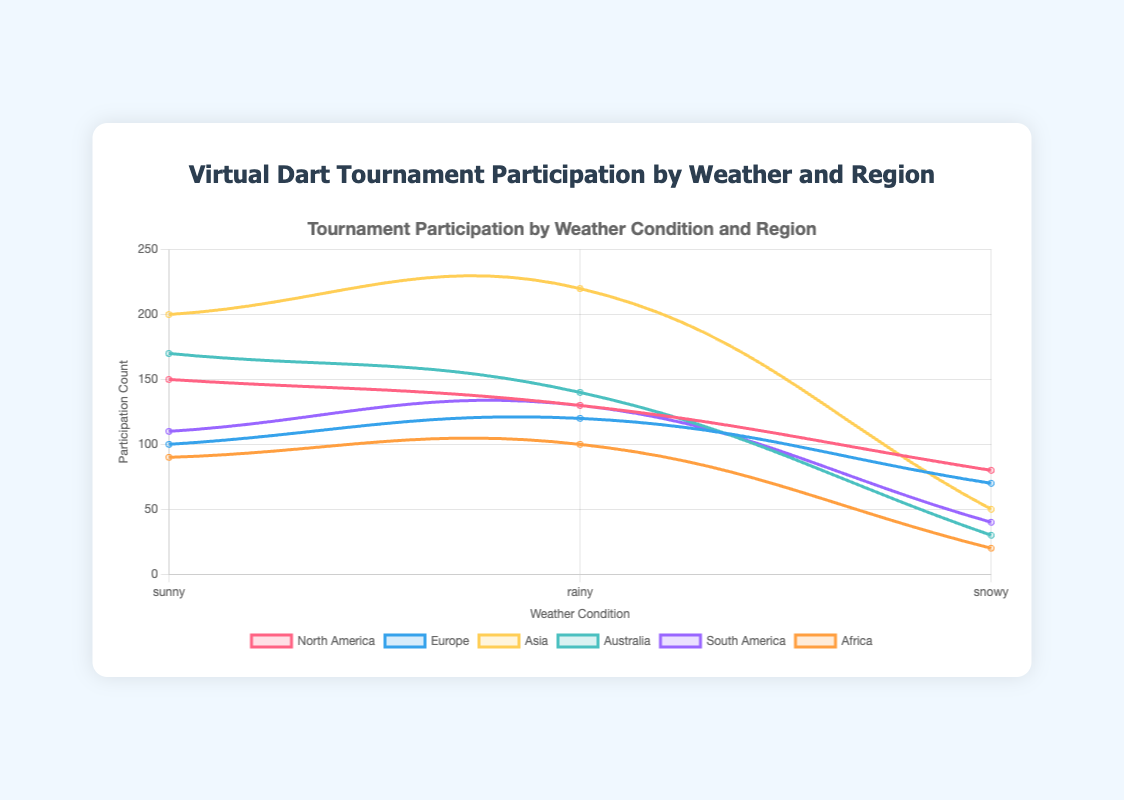Which region has the highest participation count during sunny weather? By observing the different regions during sunny weather from the plot, we identify the peak participation for North America, Europe, Asia, Australia, South America, and Africa. Comparing the heights of these data points reveals the region with the highest count.
Answer: Asia What is the combined participation count for Europe in rainy and snowy weather? Add the participation counts for Europe in rainy weather and snowy weather from the figure. Rainy weather participation is 120, and snowy weather is 70. The combined total is 120 + 70.
Answer: 190 During which weather condition is participation in South America higher? Compare the heights of the data points for South America under different weather conditions. From the plot, the highest point represents the weather condition with the highest participation count.
Answer: Rainy Compare the participation counts between Australia and North America during snowy weather. Which one is higher? Look at the data points for Australia and North America during snowy weather conditions. Compare the heights of these points to determine which is higher.
Answer: North America What is the average participation count for Africa across all weather conditions represented? To find the average, sum the participation counts for Africa in sunny, rainy, and snowy weather and divide by the number of conditions. The counts are 90 (sunny), 100 (rainy), and 20 (snowy). So, the average is (90 + 100 + 20) / 3.
Answer: 70 How many times higher is the participation count in Asia during rainy weather compared to snowy weather? Identify the participation counts for Asia during rainy and snowy weather from the plot. Rainy weather participation is 220, and snowy weather is 50. Divide the rainy count by the snowy count (220 / 50).
Answer: 4.4 times Which region shows the least variation in participation counts across different weather conditions? Check the range (difference between maximum and minimum) of the participation counts for each region across all weather conditions. The region with the smallest range exhibits the least variation.
Answer: Africa What is the participation count difference between Africa and Australia during rainy weather? Subtract the participation count of Africa during rainy weather from that of Australia. From the plot, Australia has 140, and Africa has 100 during rainy conditions. The difference is 140 - 100.
Answer: 40 In which month is the highest participation count recorded for an Asian region, and under what weather condition? Locate the highest data point for Asia and check the corresponding month and weather condition. The plot indicates this peak.
Answer: August, Rainy 